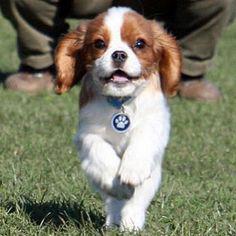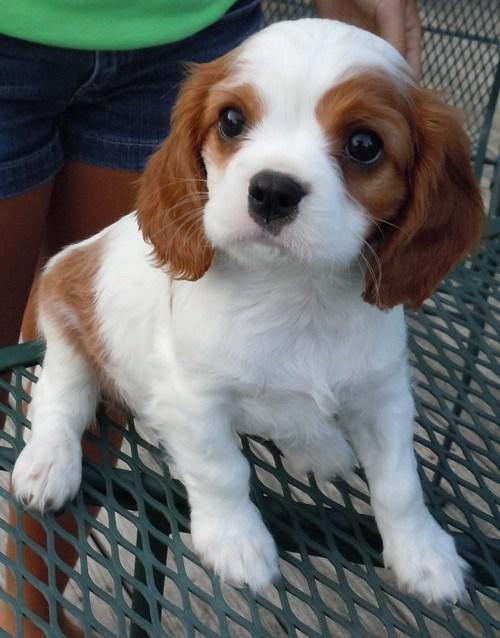The first image is the image on the left, the second image is the image on the right. Assess this claim about the two images: "One image contains twice as many spaniel pups as the other, and one image includes a hand holding a puppy.". Correct or not? Answer yes or no. No. The first image is the image on the left, the second image is the image on the right. For the images displayed, is the sentence "The left image contains exactly two dogs." factually correct? Answer yes or no. No. 